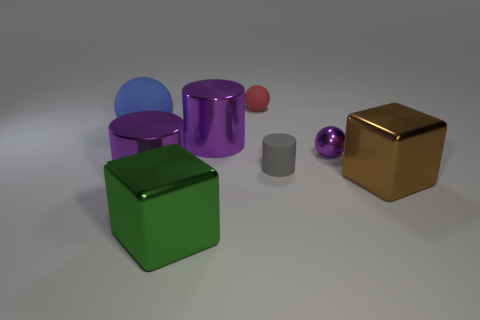There is a metal object that is both on the left side of the big brown block and on the right side of the red ball; what is its size?
Provide a short and direct response. Small. There is a large thing right of the small matte sphere; is it the same shape as the green object?
Provide a succinct answer. Yes. There is a matte sphere left of the purple metal thing that is in front of the purple ball behind the green thing; how big is it?
Your answer should be compact. Large. How many objects are either purple cylinders or big blue metallic balls?
Offer a terse response. 2. There is a rubber thing that is in front of the tiny red ball and on the left side of the gray object; what is its shape?
Provide a short and direct response. Sphere. Do the tiny red object and the small rubber thing that is in front of the small red rubber ball have the same shape?
Provide a succinct answer. No. There is a small gray cylinder; are there any gray things to the left of it?
Ensure brevity in your answer.  No. How many spheres are tiny metallic things or small red rubber things?
Your answer should be compact. 2. Does the blue thing have the same shape as the brown shiny thing?
Offer a very short reply. No. How big is the metal cylinder that is on the left side of the green block?
Your answer should be very brief. Large. 